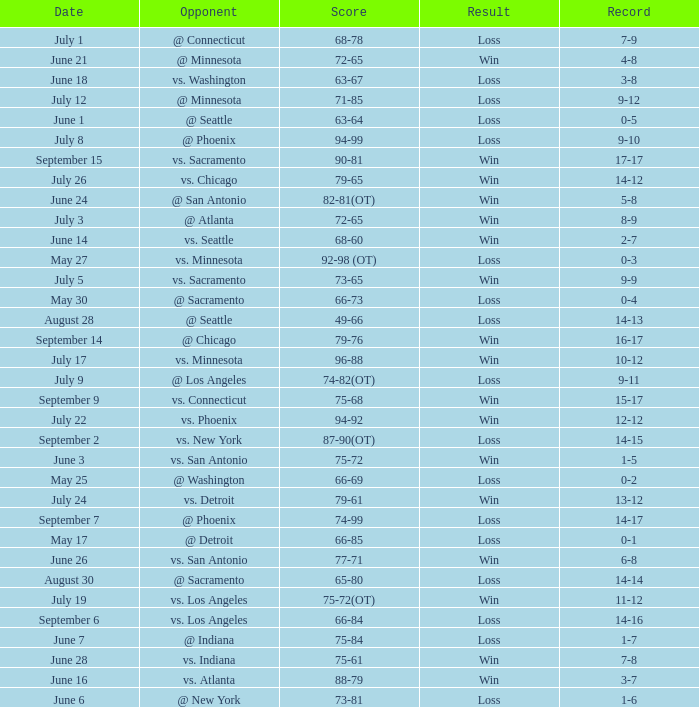What was the Score of the game with a Record of 0-1? 66-85. 